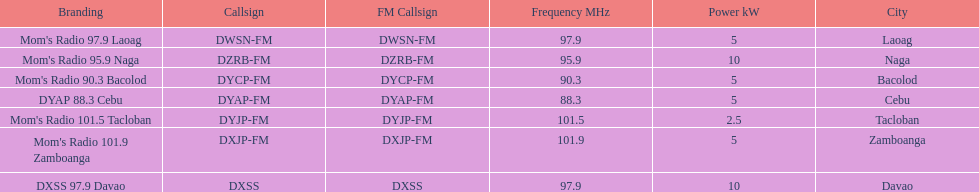What are the total number of radio stations on this list? 7. 